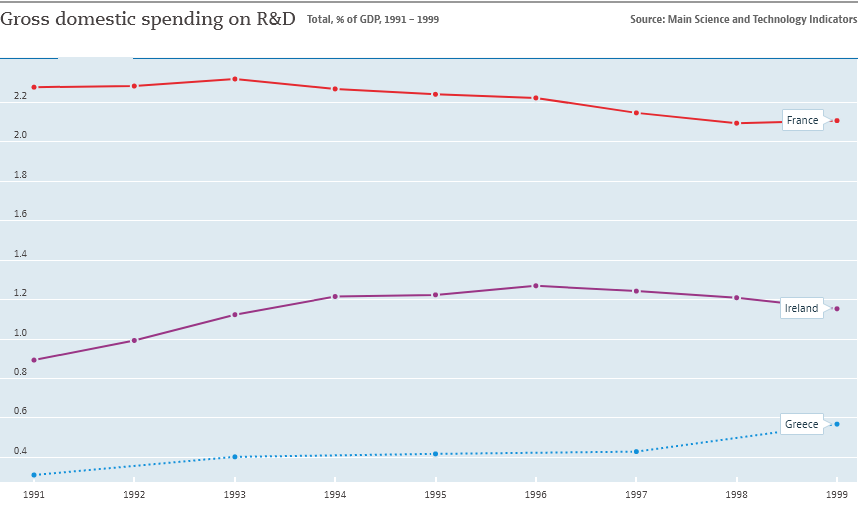Draw attention to some important aspects in this diagram. In 1996, the middle line of Ireland had the highest value. The country represented by the red line is France. 